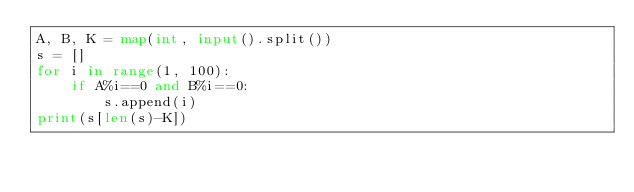Convert code to text. <code><loc_0><loc_0><loc_500><loc_500><_Python_>A, B, K = map(int, input().split())
s = []
for i in range(1, 100):
    if A%i==0 and B%i==0:
        s.append(i)
print(s[len(s)-K])</code> 